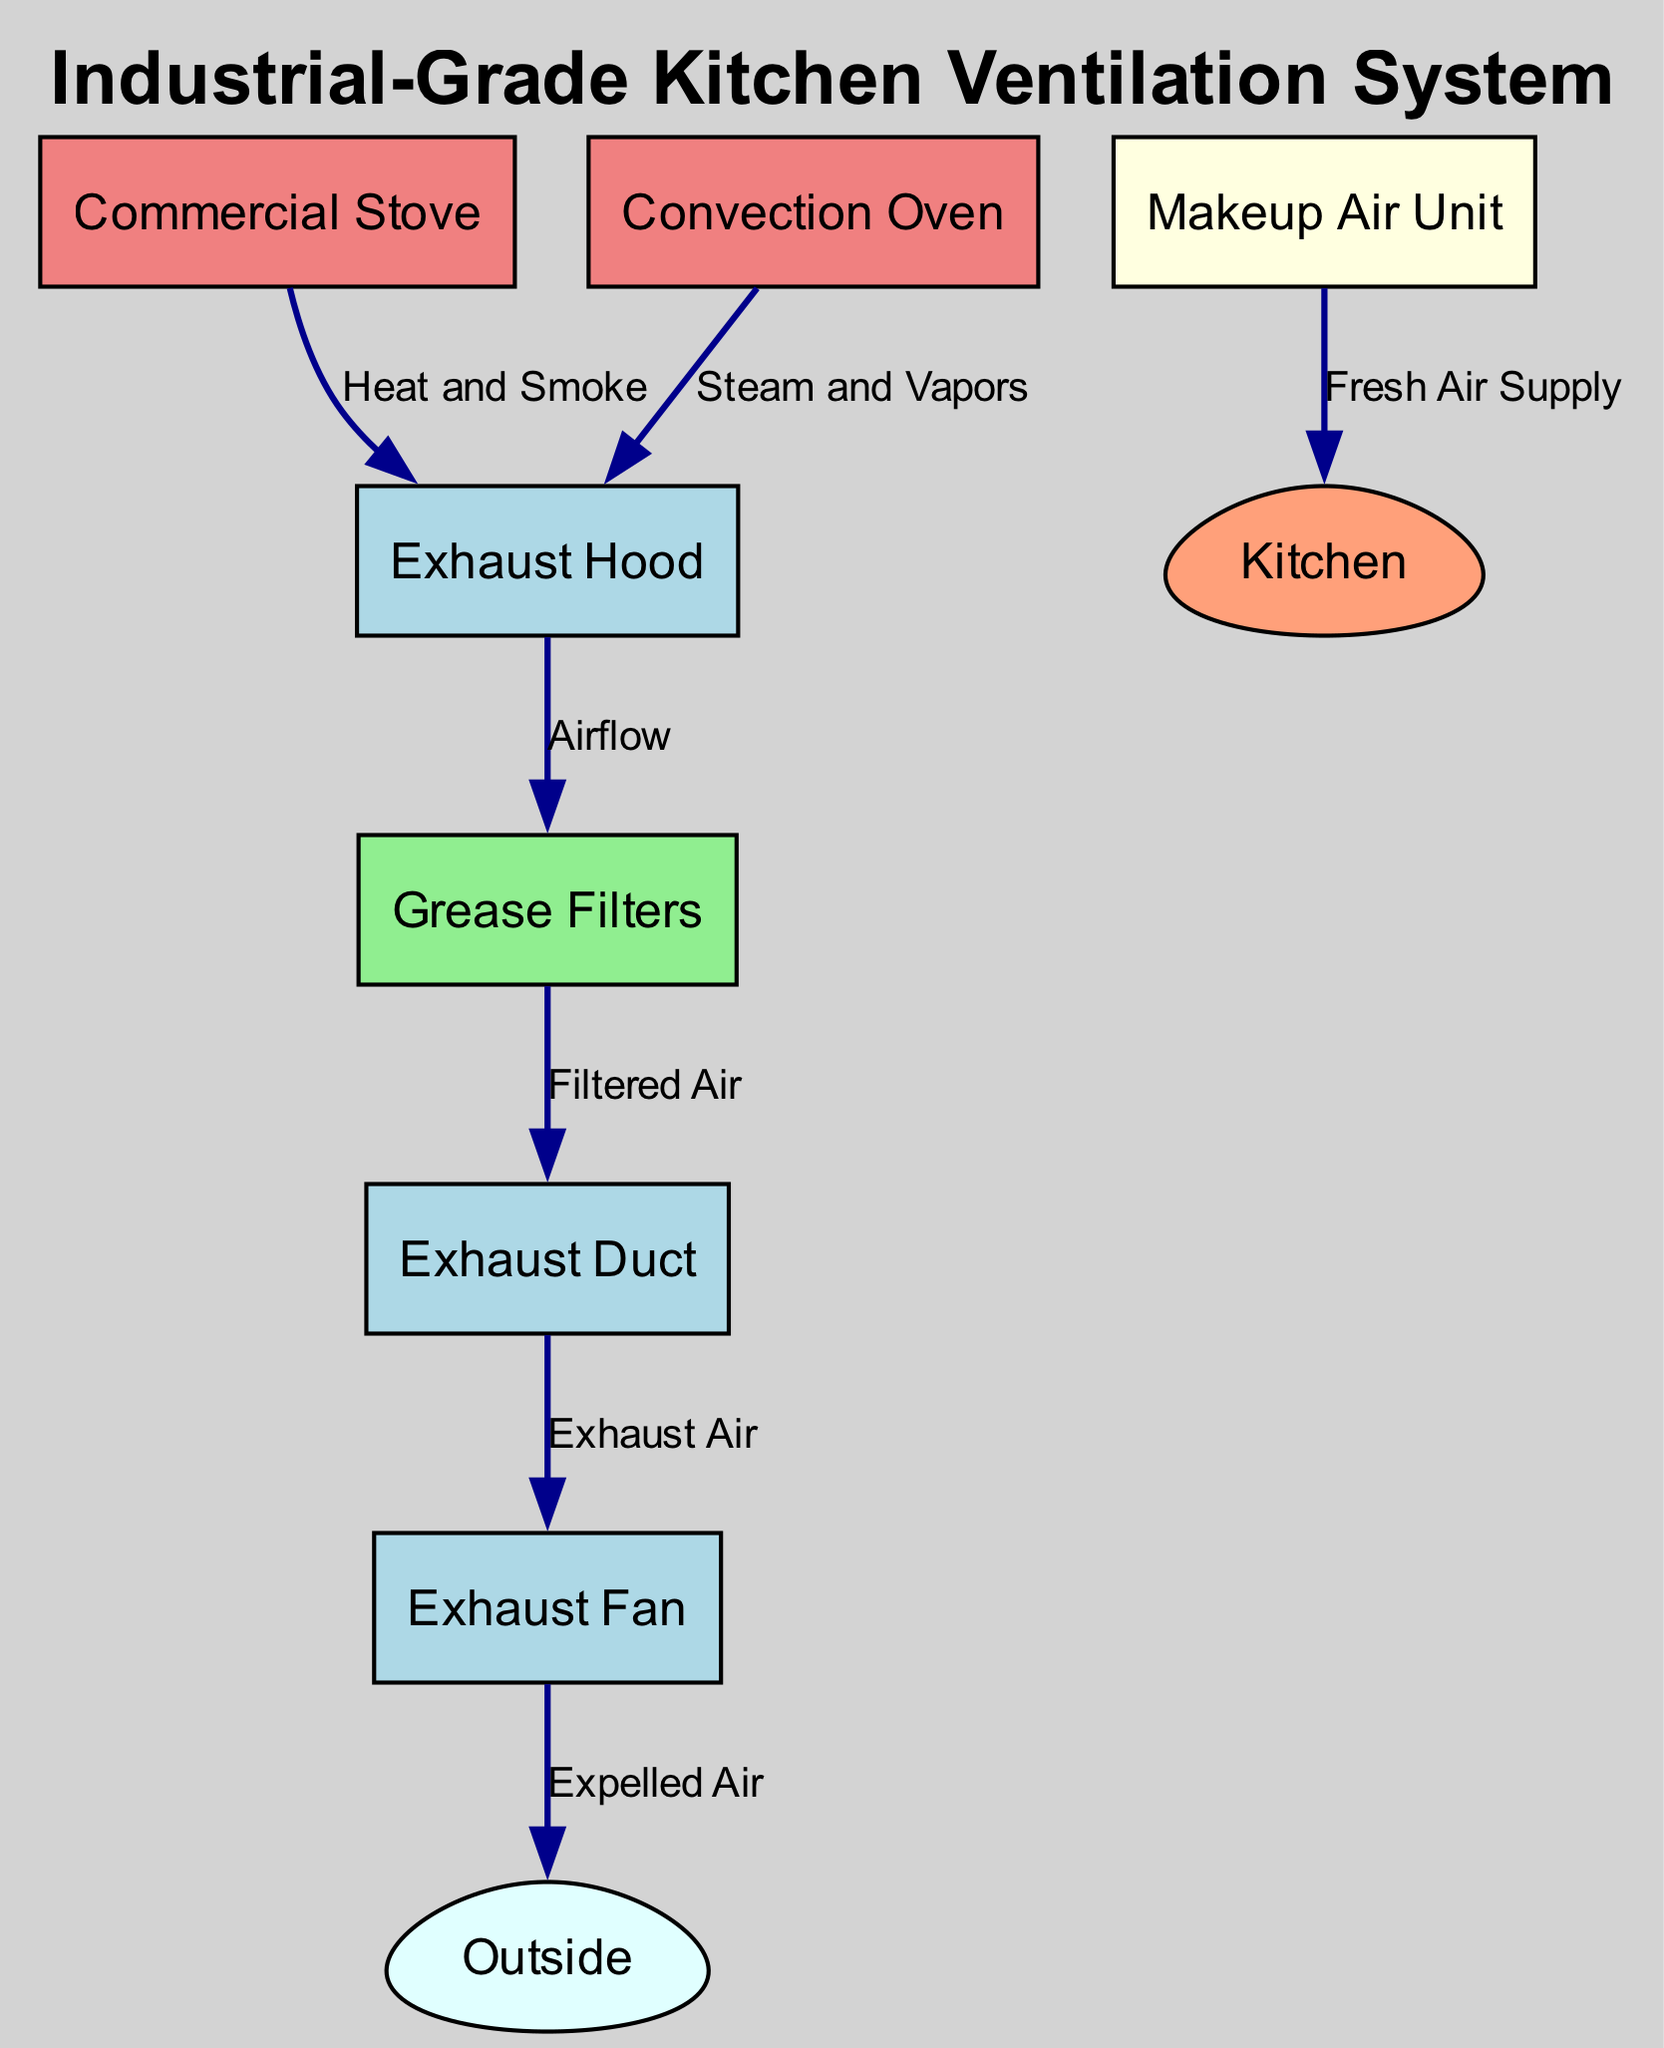What is the source of the heat and smoke entering the exhaust hood? The diagram shows that the source of the heat and smoke is the commercial stove. The edge connecting the stove to the hood indicates that these emissions flow directly from the stove to the exhaust hood.
Answer: Commercial Stove How many nodes are present in the ventilation system diagram? The diagram includes a total of seven nodes: Exhaust Hood, Exhaust Duct, Exhaust Fan, Makeup Air Unit, Grease Filters, Commercial Stove, and Convection Oven. Counting these nodes gives us the total.
Answer: Seven What type of air does the makeup unit supply to the kitchen? The diagram shows that the Makeup Air Unit supplies fresh air to the kitchen. This is indicated by the direct edge labeled that leads into the kitchen from the makeup unit.
Answer: Fresh Air Supply Which component receives filtered air from the grease filters? The grease filters are shown to send filtered air directly to the exhaust duct. This relationship is indicated by the edge connecting these two nodes, with the label "Filtered Air".
Answer: Exhaust Duct Where does the expelled air from the exhaust fan go? The exhaust fan expels air outside, as indicated by the connection from the fan to the outside node in the diagram. This edge is labeled "Expelled Air."
Answer: Outside What is the flow sequence from the commercial stove to the outside? The flow sequence starts at the Commercial Stove, which releases heat and smoke to the Exhaust Hood. The air then moves through the Grease Filters to the Exhaust Duct, is expelled by the Exhaust Fan, and finally goes Outside. This sequence identifies each step of airflow.
Answer: Stove → Hood → Grease → Duct → Fan → Outside How is steam and vapors from the convection oven handled in the system? Steam and vapors from the convection oven are channeled to the Exhaust Hood, as illustrated by the edge connecting the oven to the hood and labeled "Steam and Vapors." This indicates the initial point of removal for those emissions.
Answer: Exhaust Hood What color represents the grease filters in the diagram? The grease filters node is depicted in light green color. This color choice helps to distinguish it from other components within the diagram.
Answer: Light Green 